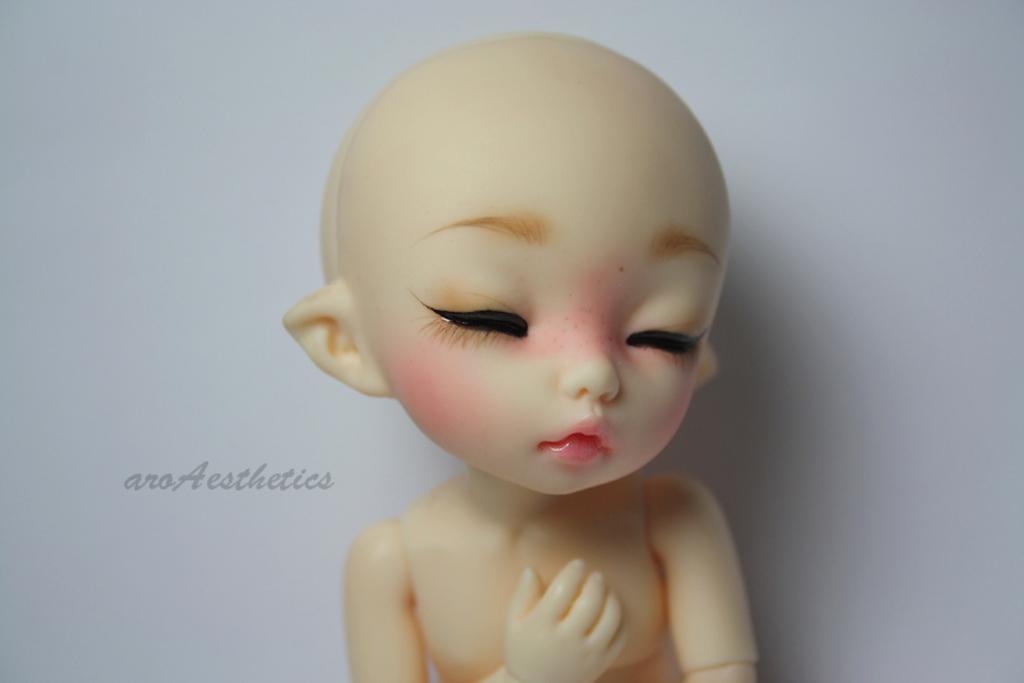Can you describe this image briefly? In this image we can see a toy and in the background, we can see the wall. 